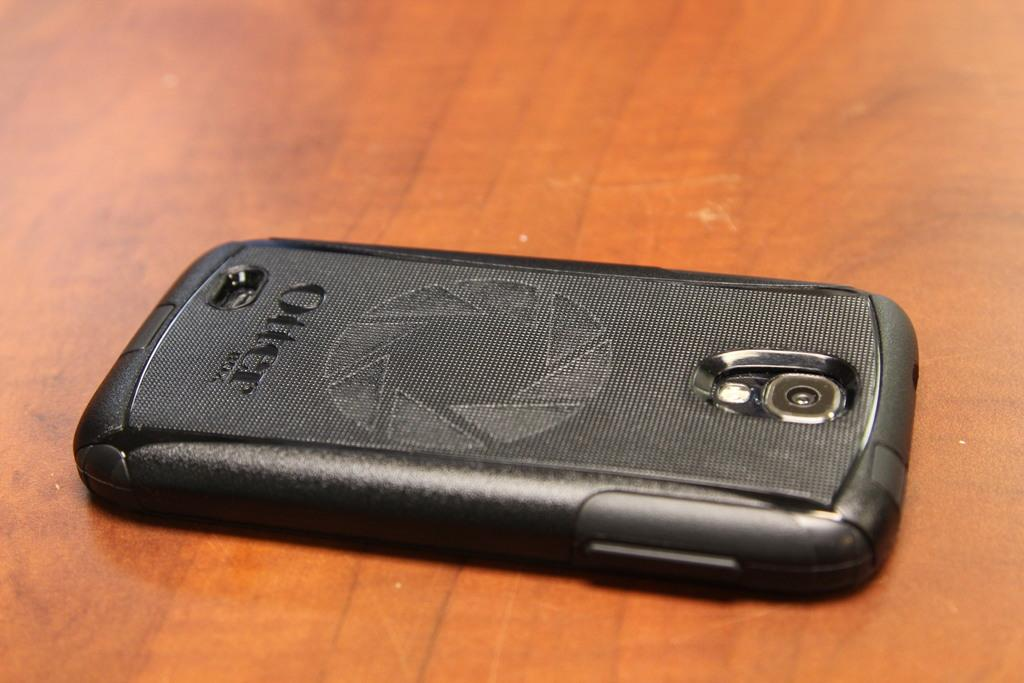Provide a one-sentence caption for the provided image. A phone that has a case with the word "Otter" on it. 